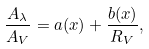Convert formula to latex. <formula><loc_0><loc_0><loc_500><loc_500>\frac { A _ { \lambda } } { A _ { V } } = a ( x ) + \frac { b ( x ) } { R _ { V } } ,</formula> 